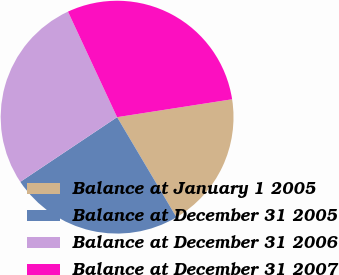Convert chart. <chart><loc_0><loc_0><loc_500><loc_500><pie_chart><fcel>Balance at January 1 2005<fcel>Balance at December 31 2005<fcel>Balance at December 31 2006<fcel>Balance at December 31 2007<nl><fcel>18.94%<fcel>24.14%<fcel>27.44%<fcel>29.48%<nl></chart> 